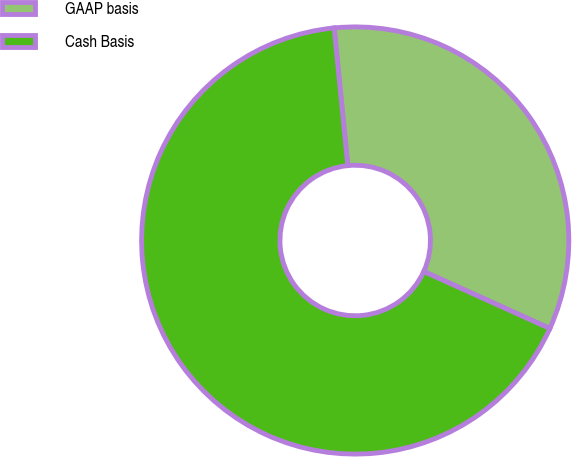Convert chart. <chart><loc_0><loc_0><loc_500><loc_500><pie_chart><fcel>GAAP basis<fcel>Cash Basis<nl><fcel>33.33%<fcel>66.67%<nl></chart> 